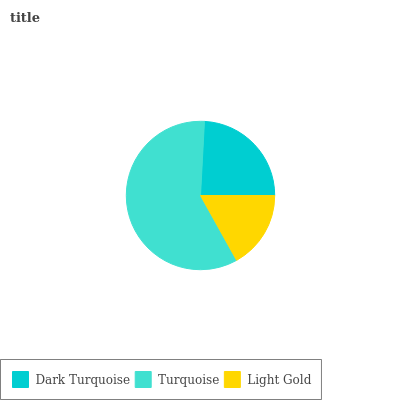Is Light Gold the minimum?
Answer yes or no. Yes. Is Turquoise the maximum?
Answer yes or no. Yes. Is Turquoise the minimum?
Answer yes or no. No. Is Light Gold the maximum?
Answer yes or no. No. Is Turquoise greater than Light Gold?
Answer yes or no. Yes. Is Light Gold less than Turquoise?
Answer yes or no. Yes. Is Light Gold greater than Turquoise?
Answer yes or no. No. Is Turquoise less than Light Gold?
Answer yes or no. No. Is Dark Turquoise the high median?
Answer yes or no. Yes. Is Dark Turquoise the low median?
Answer yes or no. Yes. Is Light Gold the high median?
Answer yes or no. No. Is Light Gold the low median?
Answer yes or no. No. 